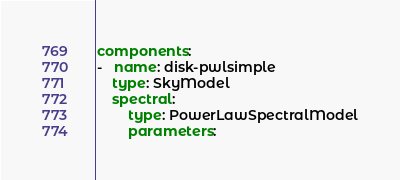<code> <loc_0><loc_0><loc_500><loc_500><_YAML_>components:
-   name: disk-pwlsimple
    type: SkyModel
    spectral:
        type: PowerLawSpectralModel
        parameters:</code> 